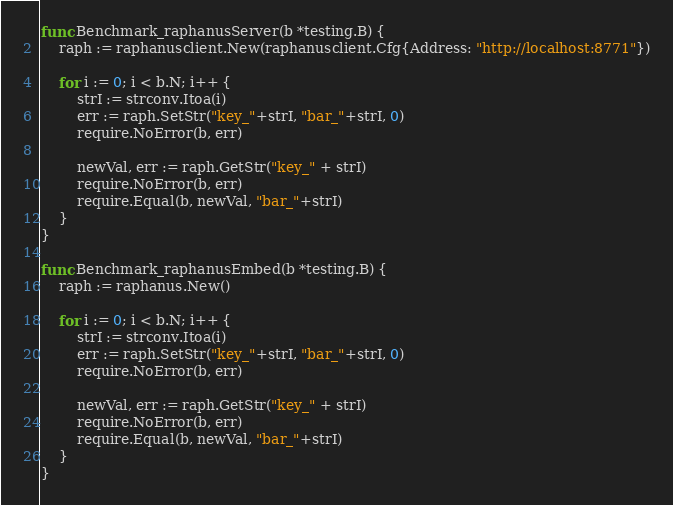<code> <loc_0><loc_0><loc_500><loc_500><_Go_>
func Benchmark_raphanusServer(b *testing.B) {
	raph := raphanusclient.New(raphanusclient.Cfg{Address: "http://localhost:8771"})

	for i := 0; i < b.N; i++ {
		strI := strconv.Itoa(i)
		err := raph.SetStr("key_"+strI, "bar_"+strI, 0)
		require.NoError(b, err)

		newVal, err := raph.GetStr("key_" + strI)
		require.NoError(b, err)
		require.Equal(b, newVal, "bar_"+strI)
	}
}

func Benchmark_raphanusEmbed(b *testing.B) {
	raph := raphanus.New()

	for i := 0; i < b.N; i++ {
		strI := strconv.Itoa(i)
		err := raph.SetStr("key_"+strI, "bar_"+strI, 0)
		require.NoError(b, err)

		newVal, err := raph.GetStr("key_" + strI)
		require.NoError(b, err)
		require.Equal(b, newVal, "bar_"+strI)
	}
}
</code> 